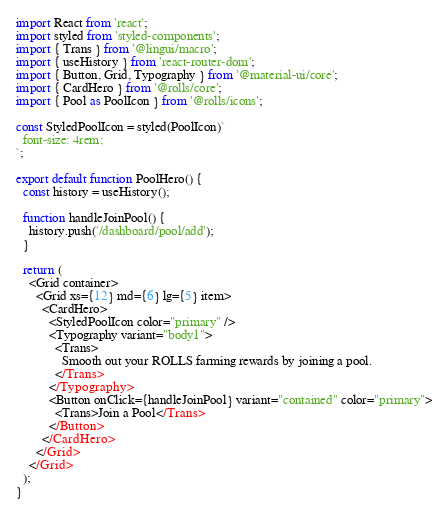<code> <loc_0><loc_0><loc_500><loc_500><_TypeScript_>import React from 'react';
import styled from 'styled-components';
import { Trans } from '@lingui/macro';
import { useHistory } from 'react-router-dom';
import { Button, Grid, Typography } from '@material-ui/core';
import { CardHero } from '@rolls/core';
import { Pool as PoolIcon } from '@rolls/icons';

const StyledPoolIcon = styled(PoolIcon)`
  font-size: 4rem;
`;

export default function PoolHero() {
  const history = useHistory();

  function handleJoinPool() {
    history.push('/dashboard/pool/add');
  }

  return (
    <Grid container>
      <Grid xs={12} md={6} lg={5} item>
        <CardHero>
          <StyledPoolIcon color="primary" />
          <Typography variant="body1">
            <Trans>
              Smooth out your ROLLS farming rewards by joining a pool.
            </Trans>
          </Typography>
          <Button onClick={handleJoinPool} variant="contained" color="primary">
            <Trans>Join a Pool</Trans>
          </Button>
        </CardHero>
      </Grid>
    </Grid>
  );
}
</code> 